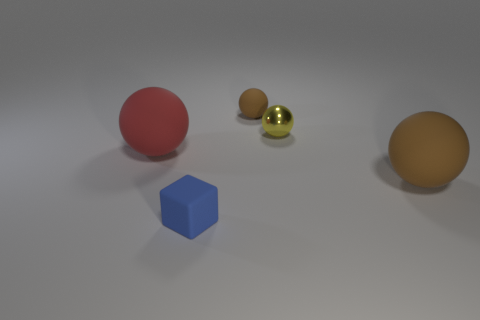Are there any spheres right of the large matte ball that is behind the brown thing right of the small yellow metallic thing?
Keep it short and to the point. Yes. What material is the other big thing that is the same shape as the large red object?
Offer a terse response. Rubber. Is there any other thing that has the same material as the yellow sphere?
Your answer should be very brief. No. How many spheres are either yellow shiny objects or brown rubber things?
Make the answer very short. 3. Do the brown rubber object behind the yellow object and the ball that is to the left of the small blue block have the same size?
Provide a succinct answer. No. What material is the tiny yellow sphere to the right of the matte sphere on the left side of the tiny brown rubber object?
Ensure brevity in your answer.  Metal. Are there fewer objects that are behind the small blue thing than tiny brown rubber balls?
Your answer should be compact. No. The red thing that is the same material as the blue block is what shape?
Provide a succinct answer. Sphere. How many other objects are there of the same shape as the tiny blue thing?
Your response must be concise. 0. How many blue objects are tiny matte objects or tiny blocks?
Provide a succinct answer. 1. 